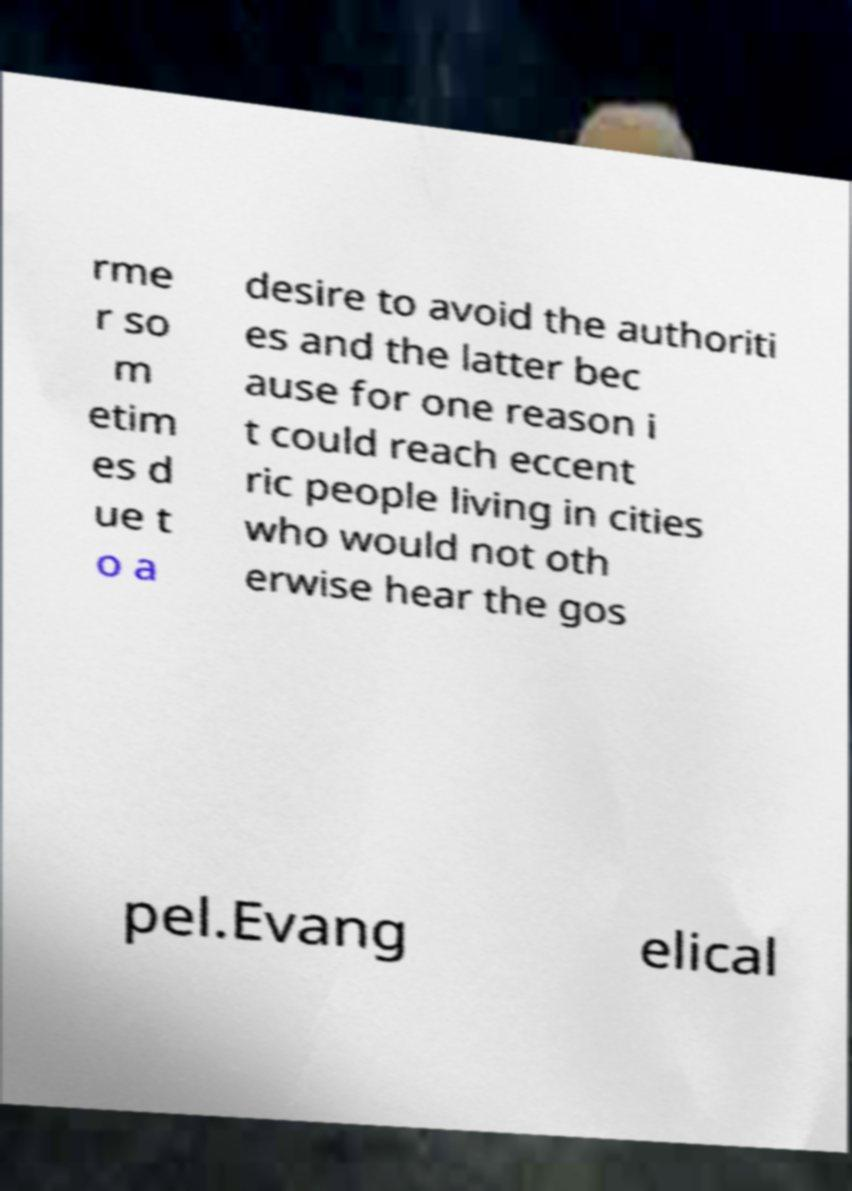Can you read and provide the text displayed in the image?This photo seems to have some interesting text. Can you extract and type it out for me? rme r so m etim es d ue t o a desire to avoid the authoriti es and the latter bec ause for one reason i t could reach eccent ric people living in cities who would not oth erwise hear the gos pel.Evang elical 